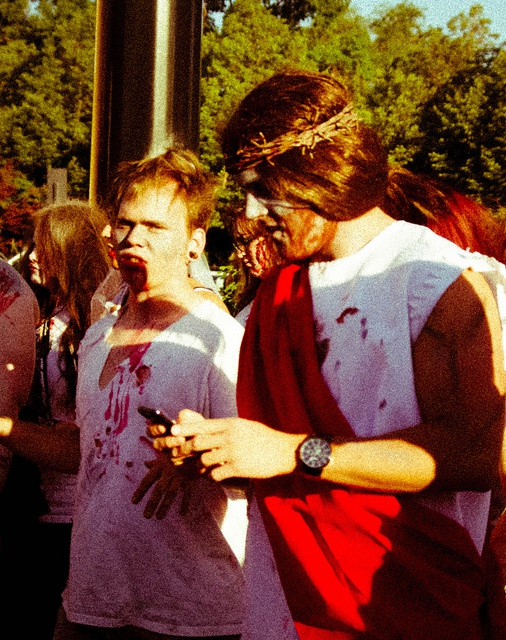Describe the objects in this image and their specific colors. I can see people in black, maroon, red, and darkgray tones, people in black, maroon, purple, and brown tones, people in black, maroon, and brown tones, people in black, maroon, ivory, and khaki tones, and people in black, maroon, and brown tones in this image. 